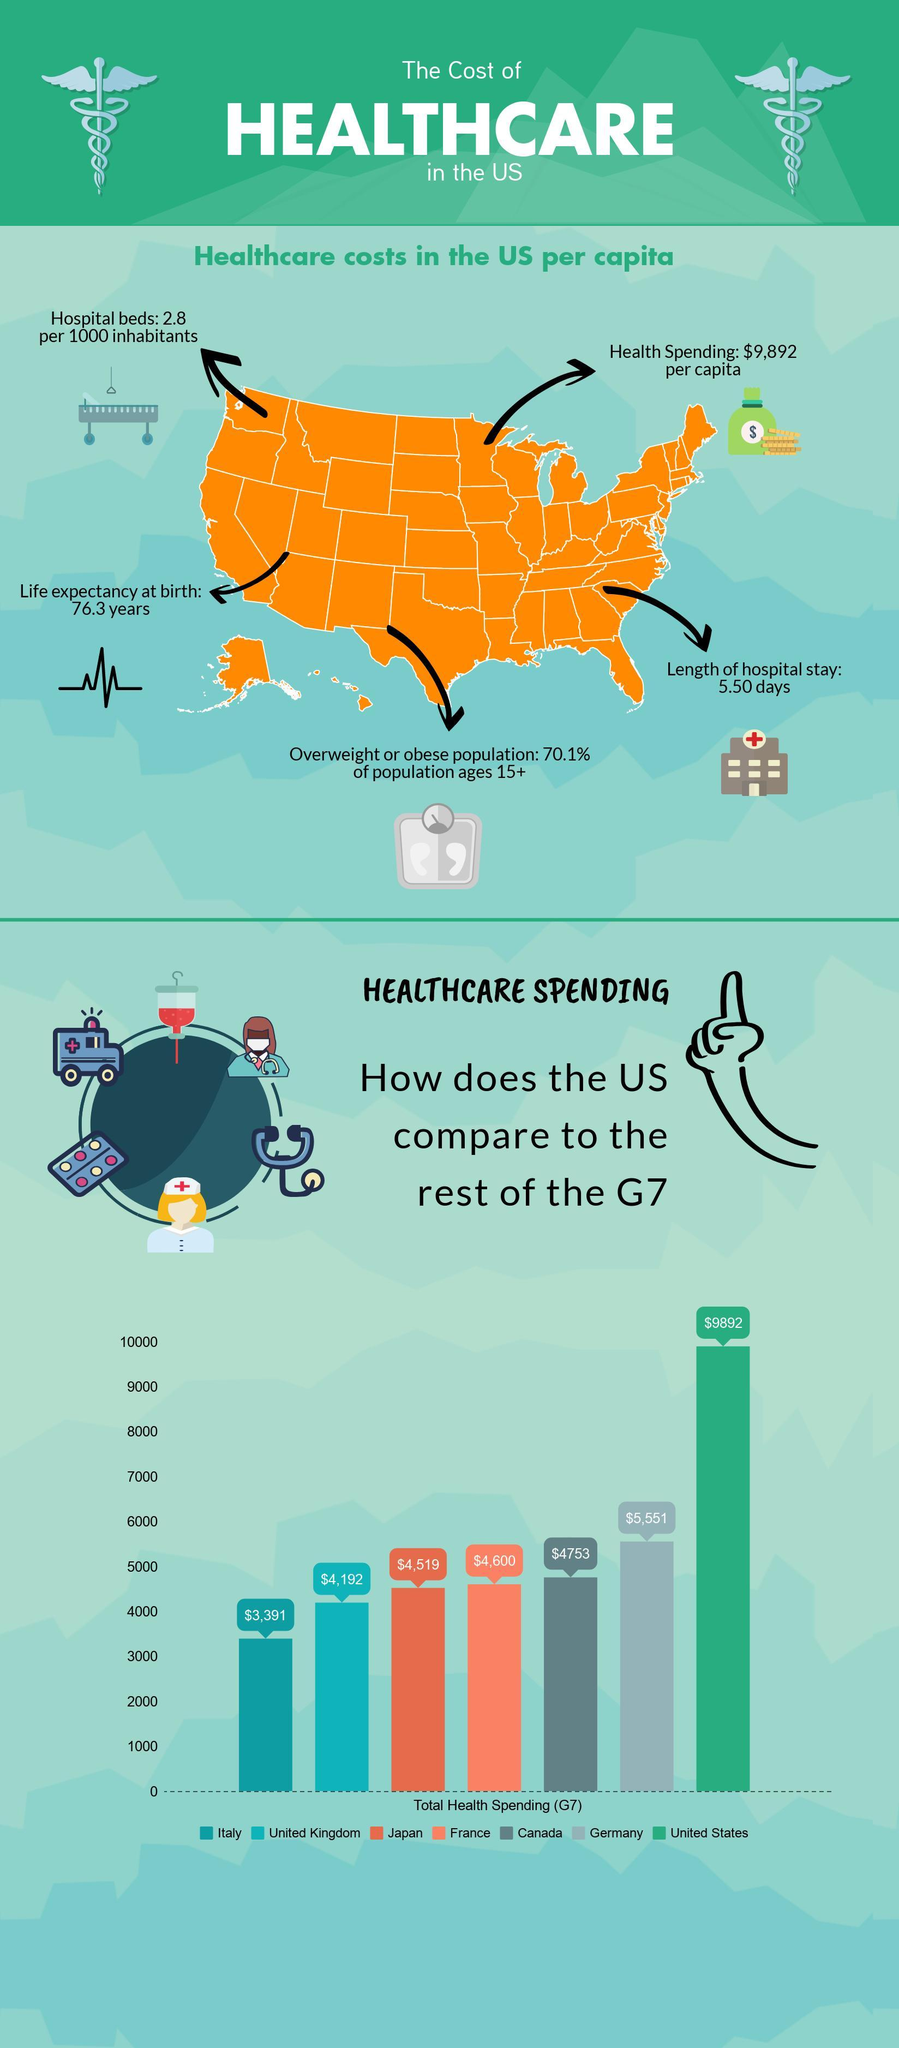How much does France and Canada together spend on healthcare?
Answer the question with a short phrase. $9,353 How much does Japan spend on healthcare? $4,519 Which country spends lesser than the United Kingdom on healthcare? Italy 